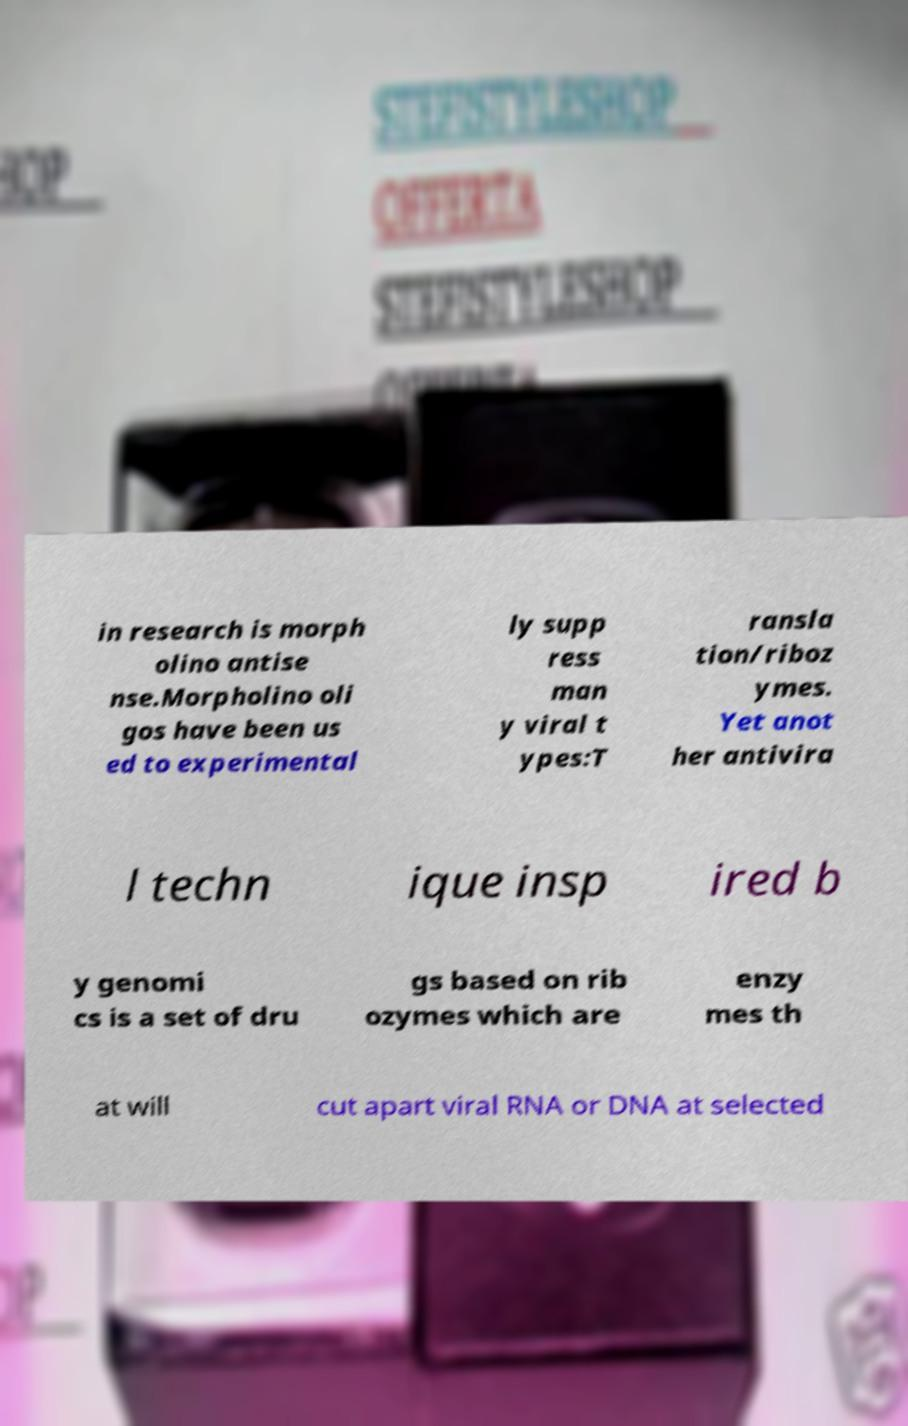Could you extract and type out the text from this image? in research is morph olino antise nse.Morpholino oli gos have been us ed to experimental ly supp ress man y viral t ypes:T ransla tion/riboz ymes. Yet anot her antivira l techn ique insp ired b y genomi cs is a set of dru gs based on rib ozymes which are enzy mes th at will cut apart viral RNA or DNA at selected 